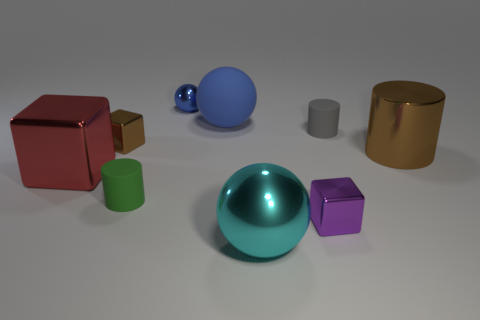Are there any other things that have the same color as the large block?
Keep it short and to the point. No. How many other things are made of the same material as the brown cube?
Your answer should be compact. 5. How many green matte cylinders are there?
Make the answer very short. 1. There is a red thing that is the same shape as the purple metallic thing; what material is it?
Your answer should be very brief. Metal. Do the brown thing left of the large blue ball and the tiny blue ball have the same material?
Your response must be concise. Yes. Are there more large cubes that are to the right of the small blue metal sphere than big red objects behind the big blue object?
Your answer should be compact. No. What size is the blue rubber ball?
Offer a terse response. Large. What shape is the gray thing that is the same material as the green cylinder?
Ensure brevity in your answer.  Cylinder. There is a object that is on the right side of the gray cylinder; is its shape the same as the green thing?
Offer a very short reply. Yes. How many objects are either big cylinders or large matte balls?
Your response must be concise. 2. 